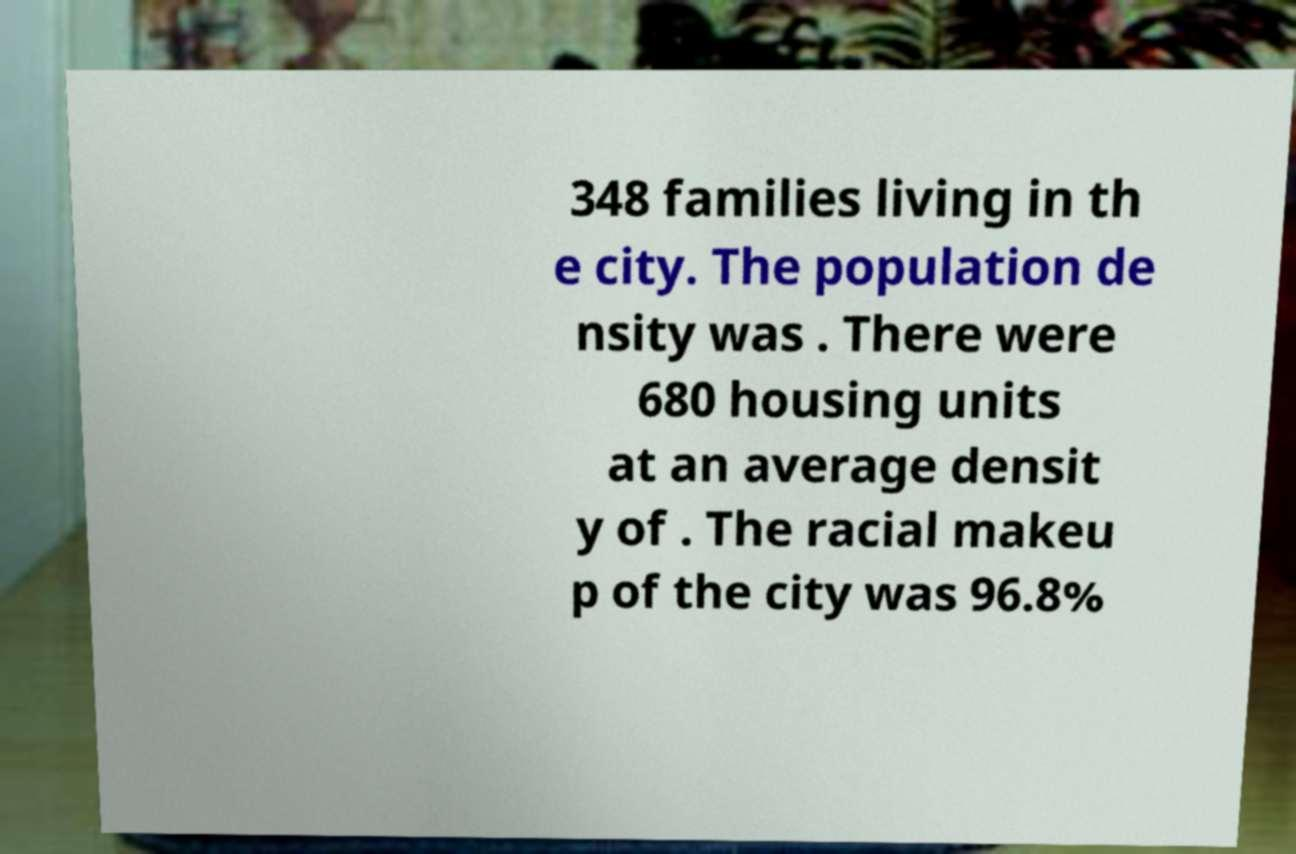Can you accurately transcribe the text from the provided image for me? 348 families living in th e city. The population de nsity was . There were 680 housing units at an average densit y of . The racial makeu p of the city was 96.8% 